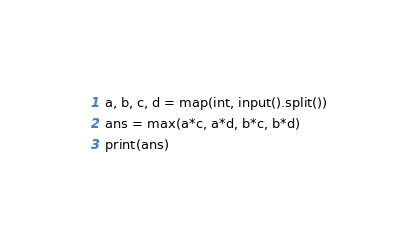<code> <loc_0><loc_0><loc_500><loc_500><_Python_>a, b, c, d = map(int, input().split())
ans = max(a*c, a*d, b*c, b*d)
print(ans)</code> 